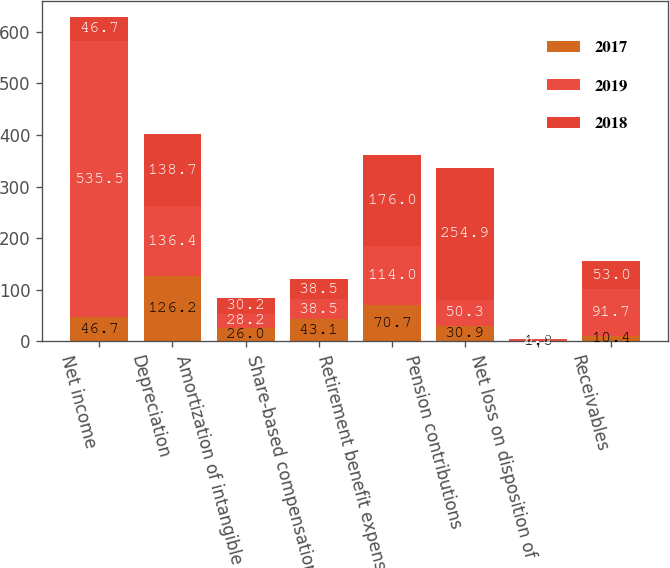<chart> <loc_0><loc_0><loc_500><loc_500><stacked_bar_chart><ecel><fcel>Net income<fcel>Depreciation<fcel>Amortization of intangible<fcel>Share-based compensation<fcel>Retirement benefit expense<fcel>Pension contributions<fcel>Net loss on disposition of<fcel>Receivables<nl><fcel>2017<fcel>46.7<fcel>126.2<fcel>26<fcel>43.1<fcel>70.7<fcel>30.9<fcel>1.8<fcel>10.4<nl><fcel>2019<fcel>535.5<fcel>136.4<fcel>28.2<fcel>38.5<fcel>114<fcel>50.3<fcel>2.5<fcel>91.7<nl><fcel>2018<fcel>46.7<fcel>138.7<fcel>30.2<fcel>38.5<fcel>176<fcel>254.9<fcel>0.1<fcel>53<nl></chart> 